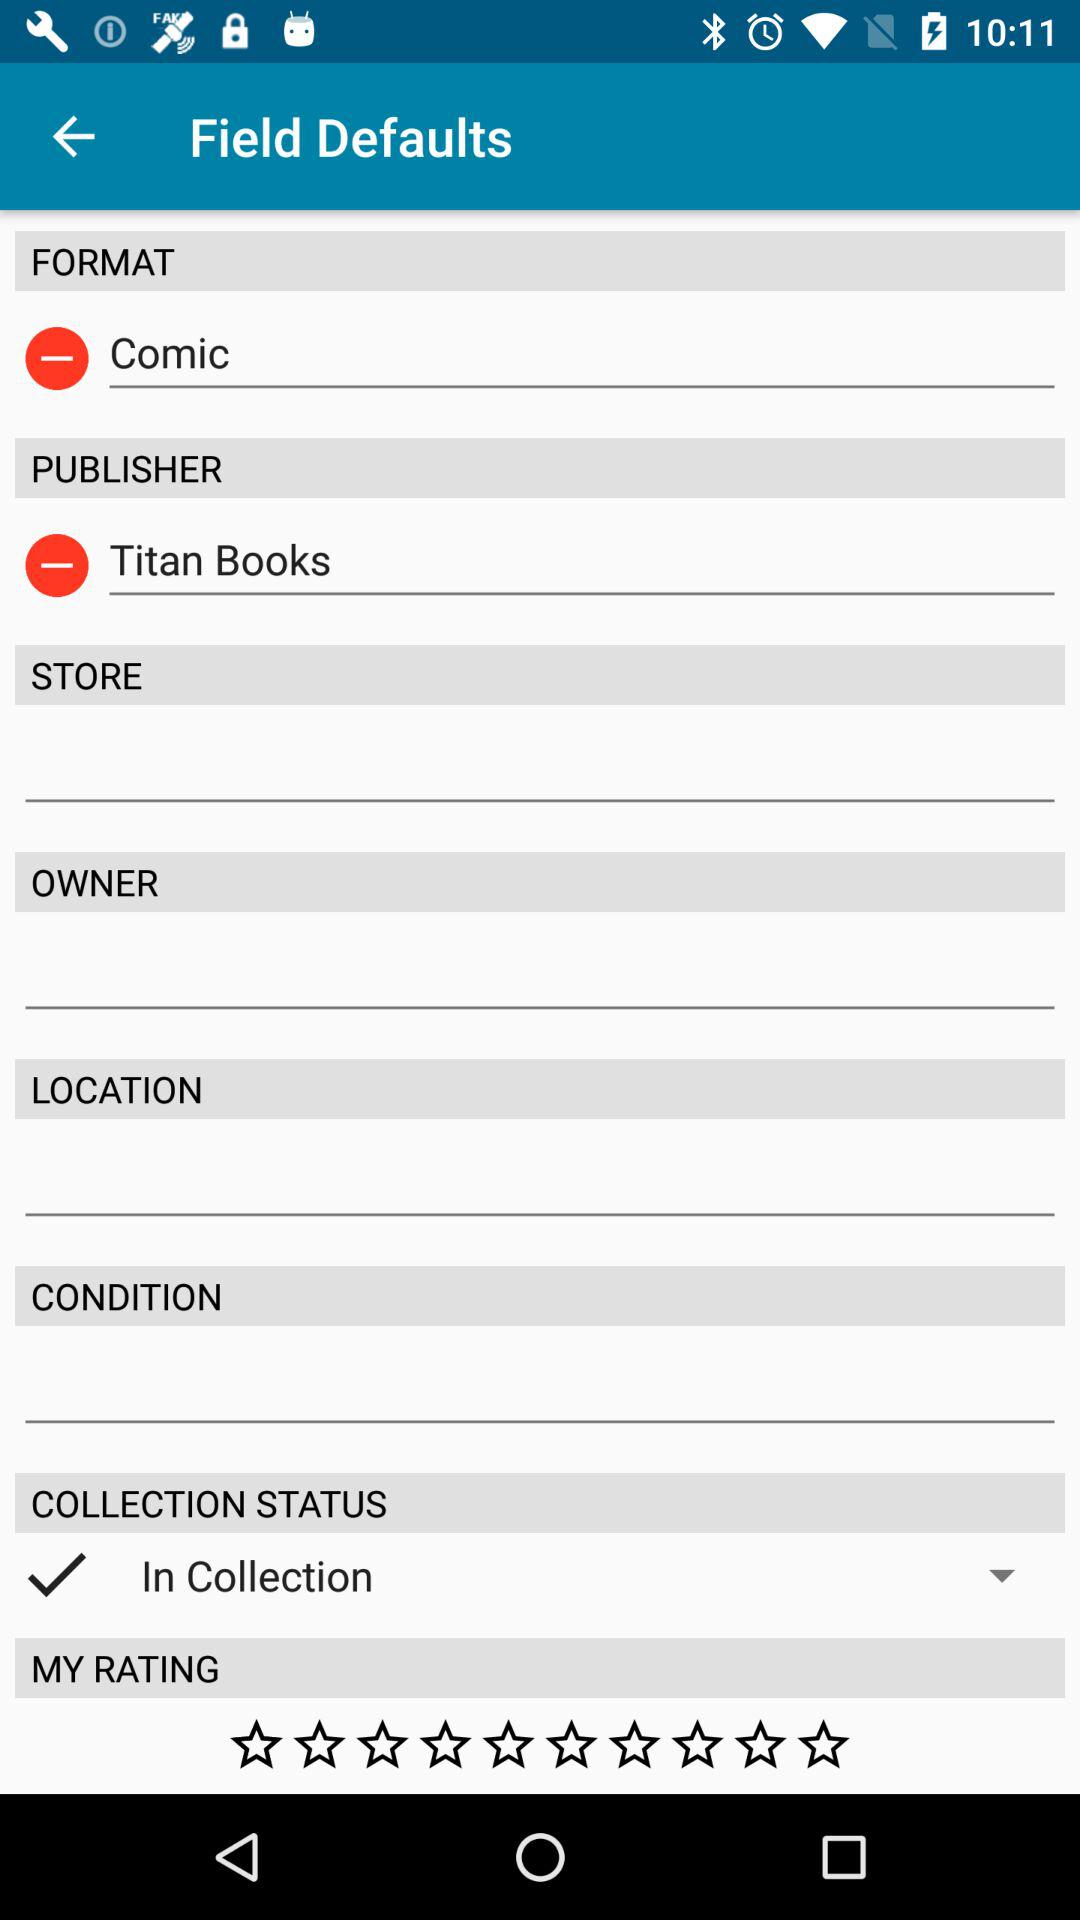Which option is checked? The checked option is "In Collection". 